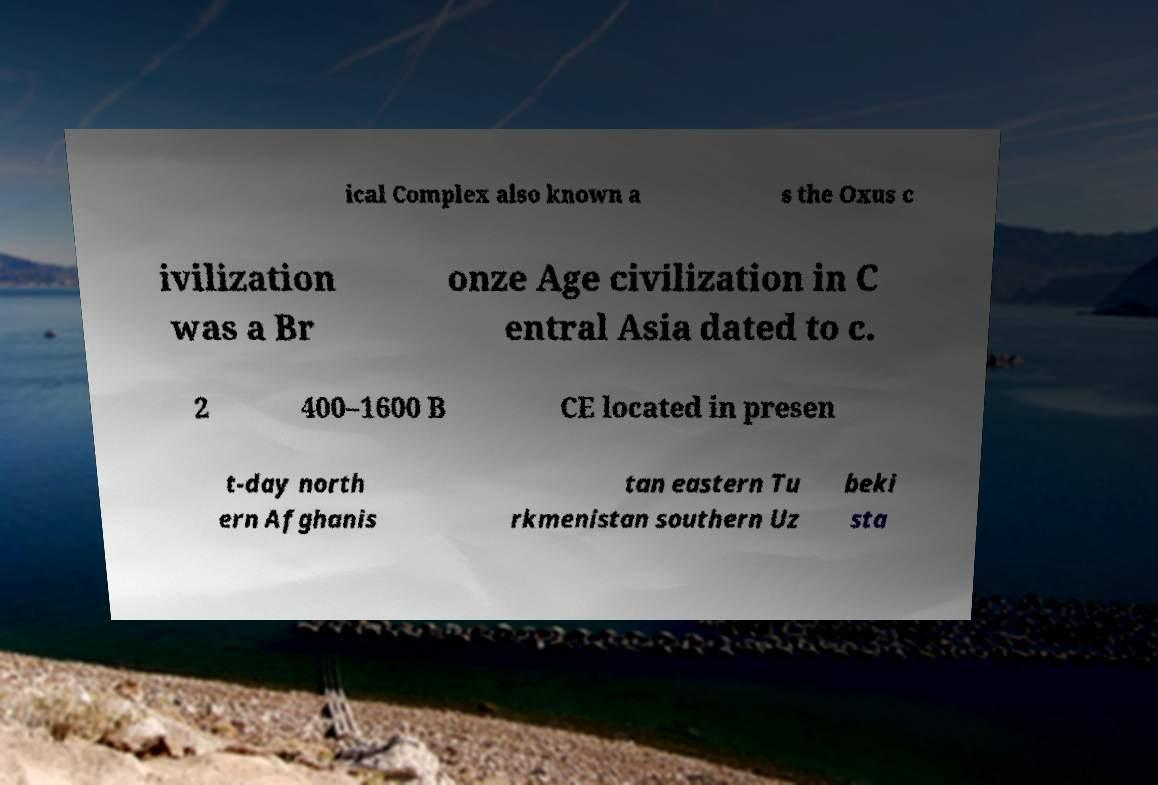Can you accurately transcribe the text from the provided image for me? ical Complex also known a s the Oxus c ivilization was a Br onze Age civilization in C entral Asia dated to c. 2 400–1600 B CE located in presen t-day north ern Afghanis tan eastern Tu rkmenistan southern Uz beki sta 